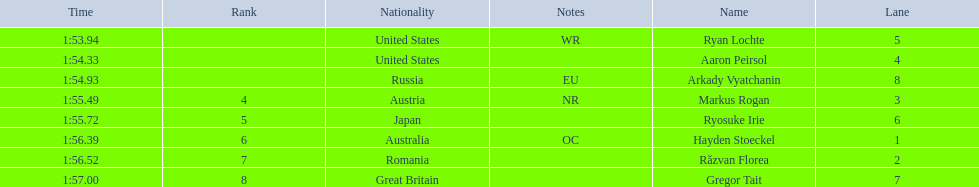What is the name of the contestant in lane 6? Ryosuke Irie. How long did it take that player to complete the race? 1:55.72. 